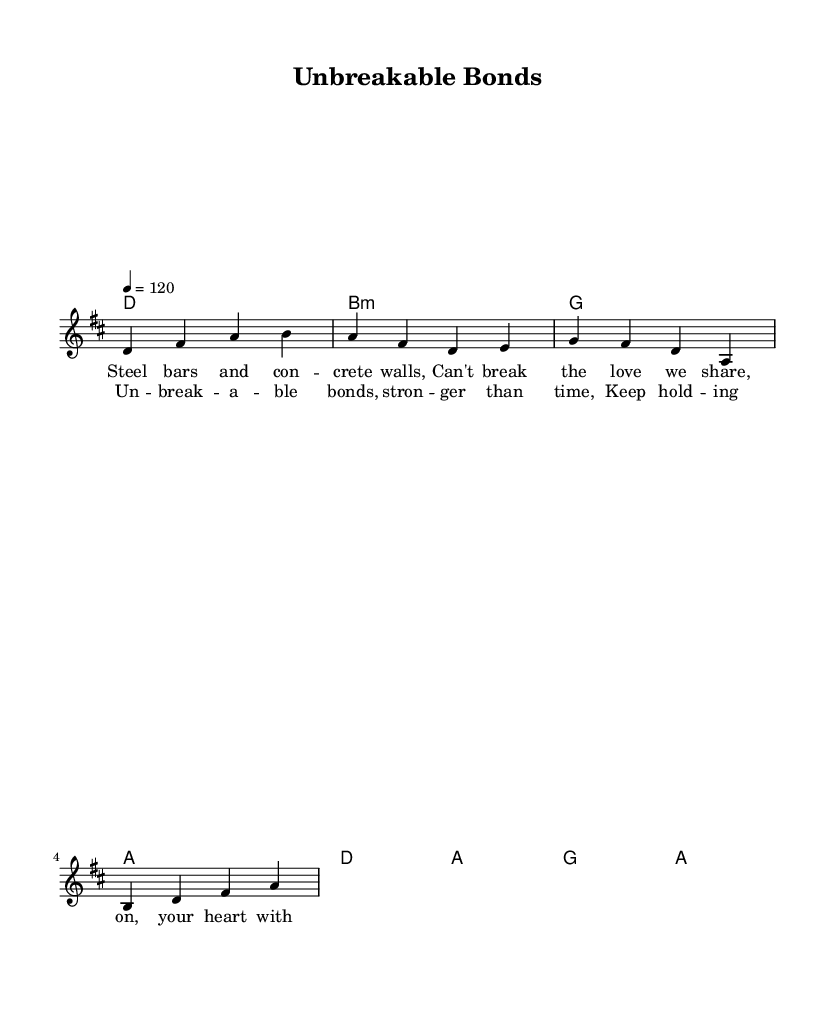What is the key signature of this music? The key signature is D major, which has two sharps (F# and C#). You can find the key signature usually indicated at the beginning of the staff.
Answer: D major What is the time signature of this music? The time signature is 4/4, which means there are four beats per measure. This information is shown right after the key signature in the score.
Answer: 4/4 What is the tempo marking of this piece? The tempo marking is 120 beats per minute. It is indicated above the staff at the beginning of the score.
Answer: 120 How many measures are in the melody section? There are four measures in the melody section. This can be determined by counting the groups of beats or bars marked by vertical lines in the staff.
Answer: 4 What is the first lyric line of the verse? The first lyric line of the verse is "Steel bars and concrete walls." This is noted below the melody section, matching the corresponding melody notes.
Answer: Steel bars and concrete walls What emotion do the lyrics convey about family bonds? The lyrics convey a sense of resilience and strength despite physical separation, emphasizing that love persists even through challenges. This can be interpreted from the themes presented in both the verse and chorus sections of the music.
Answer: Resilience How does the harmony contribute to the overall punk feel of the song? The harmony includes strong, straightforward chords typically found in punk music, such as major and minor triads, creating an energetic and powerful sound. The harmonic choices reflect the genre's characteristics of simplicity and emotional honesty.
Answer: Energetic 